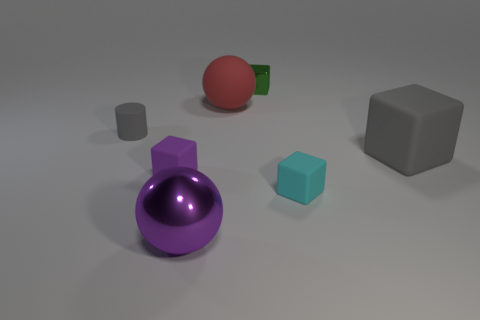Subtract 1 blocks. How many blocks are left? 3 Add 3 tiny cyan matte cubes. How many objects exist? 10 Subtract all spheres. How many objects are left? 5 Subtract all green metal things. Subtract all yellow metallic spheres. How many objects are left? 6 Add 1 small gray matte cylinders. How many small gray matte cylinders are left? 2 Add 2 big rubber objects. How many big rubber objects exist? 4 Subtract 1 cyan cubes. How many objects are left? 6 